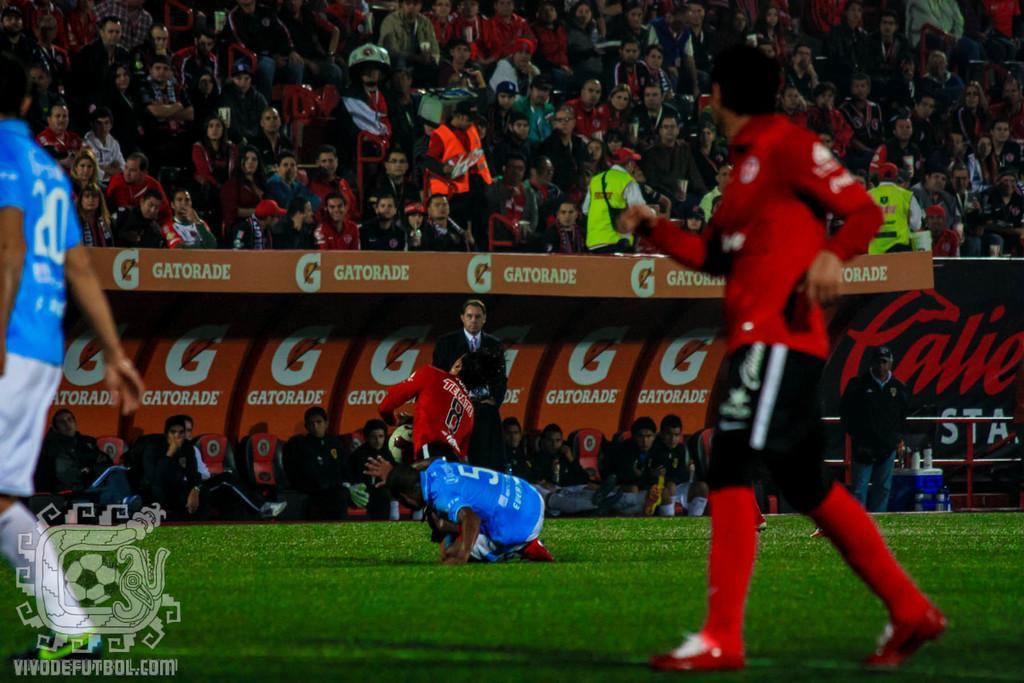Can you describe this image briefly? In this picture there are sportsmen on the right and left side of the image, on the grassland and there are people those who are sitting in the background area of the image, as audience, there are posters in the background area of the image. 